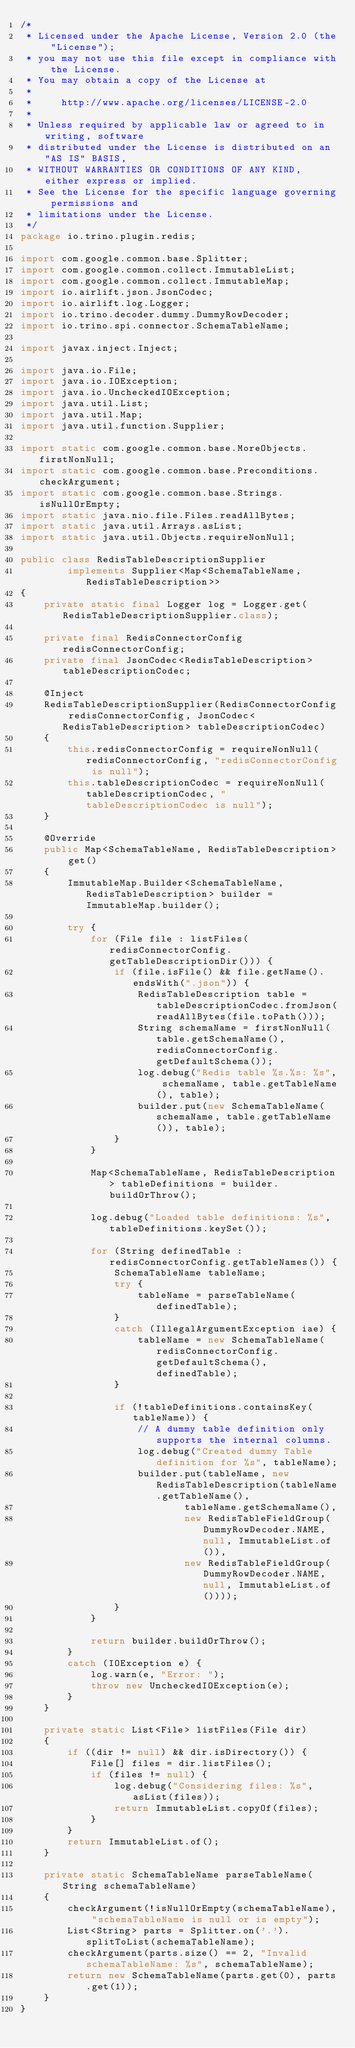<code> <loc_0><loc_0><loc_500><loc_500><_Java_>/*
 * Licensed under the Apache License, Version 2.0 (the "License");
 * you may not use this file except in compliance with the License.
 * You may obtain a copy of the License at
 *
 *     http://www.apache.org/licenses/LICENSE-2.0
 *
 * Unless required by applicable law or agreed to in writing, software
 * distributed under the License is distributed on an "AS IS" BASIS,
 * WITHOUT WARRANTIES OR CONDITIONS OF ANY KIND, either express or implied.
 * See the License for the specific language governing permissions and
 * limitations under the License.
 */
package io.trino.plugin.redis;

import com.google.common.base.Splitter;
import com.google.common.collect.ImmutableList;
import com.google.common.collect.ImmutableMap;
import io.airlift.json.JsonCodec;
import io.airlift.log.Logger;
import io.trino.decoder.dummy.DummyRowDecoder;
import io.trino.spi.connector.SchemaTableName;

import javax.inject.Inject;

import java.io.File;
import java.io.IOException;
import java.io.UncheckedIOException;
import java.util.List;
import java.util.Map;
import java.util.function.Supplier;

import static com.google.common.base.MoreObjects.firstNonNull;
import static com.google.common.base.Preconditions.checkArgument;
import static com.google.common.base.Strings.isNullOrEmpty;
import static java.nio.file.Files.readAllBytes;
import static java.util.Arrays.asList;
import static java.util.Objects.requireNonNull;

public class RedisTableDescriptionSupplier
        implements Supplier<Map<SchemaTableName, RedisTableDescription>>
{
    private static final Logger log = Logger.get(RedisTableDescriptionSupplier.class);

    private final RedisConnectorConfig redisConnectorConfig;
    private final JsonCodec<RedisTableDescription> tableDescriptionCodec;

    @Inject
    RedisTableDescriptionSupplier(RedisConnectorConfig redisConnectorConfig, JsonCodec<RedisTableDescription> tableDescriptionCodec)
    {
        this.redisConnectorConfig = requireNonNull(redisConnectorConfig, "redisConnectorConfig is null");
        this.tableDescriptionCodec = requireNonNull(tableDescriptionCodec, "tableDescriptionCodec is null");
    }

    @Override
    public Map<SchemaTableName, RedisTableDescription> get()
    {
        ImmutableMap.Builder<SchemaTableName, RedisTableDescription> builder = ImmutableMap.builder();

        try {
            for (File file : listFiles(redisConnectorConfig.getTableDescriptionDir())) {
                if (file.isFile() && file.getName().endsWith(".json")) {
                    RedisTableDescription table = tableDescriptionCodec.fromJson(readAllBytes(file.toPath()));
                    String schemaName = firstNonNull(table.getSchemaName(), redisConnectorConfig.getDefaultSchema());
                    log.debug("Redis table %s.%s: %s", schemaName, table.getTableName(), table);
                    builder.put(new SchemaTableName(schemaName, table.getTableName()), table);
                }
            }

            Map<SchemaTableName, RedisTableDescription> tableDefinitions = builder.buildOrThrow();

            log.debug("Loaded table definitions: %s", tableDefinitions.keySet());

            for (String definedTable : redisConnectorConfig.getTableNames()) {
                SchemaTableName tableName;
                try {
                    tableName = parseTableName(definedTable);
                }
                catch (IllegalArgumentException iae) {
                    tableName = new SchemaTableName(redisConnectorConfig.getDefaultSchema(), definedTable);
                }

                if (!tableDefinitions.containsKey(tableName)) {
                    // A dummy table definition only supports the internal columns.
                    log.debug("Created dummy Table definition for %s", tableName);
                    builder.put(tableName, new RedisTableDescription(tableName.getTableName(),
                            tableName.getSchemaName(),
                            new RedisTableFieldGroup(DummyRowDecoder.NAME, null, ImmutableList.of()),
                            new RedisTableFieldGroup(DummyRowDecoder.NAME, null, ImmutableList.of())));
                }
            }

            return builder.buildOrThrow();
        }
        catch (IOException e) {
            log.warn(e, "Error: ");
            throw new UncheckedIOException(e);
        }
    }

    private static List<File> listFiles(File dir)
    {
        if ((dir != null) && dir.isDirectory()) {
            File[] files = dir.listFiles();
            if (files != null) {
                log.debug("Considering files: %s", asList(files));
                return ImmutableList.copyOf(files);
            }
        }
        return ImmutableList.of();
    }

    private static SchemaTableName parseTableName(String schemaTableName)
    {
        checkArgument(!isNullOrEmpty(schemaTableName), "schemaTableName is null or is empty");
        List<String> parts = Splitter.on('.').splitToList(schemaTableName);
        checkArgument(parts.size() == 2, "Invalid schemaTableName: %s", schemaTableName);
        return new SchemaTableName(parts.get(0), parts.get(1));
    }
}
</code> 